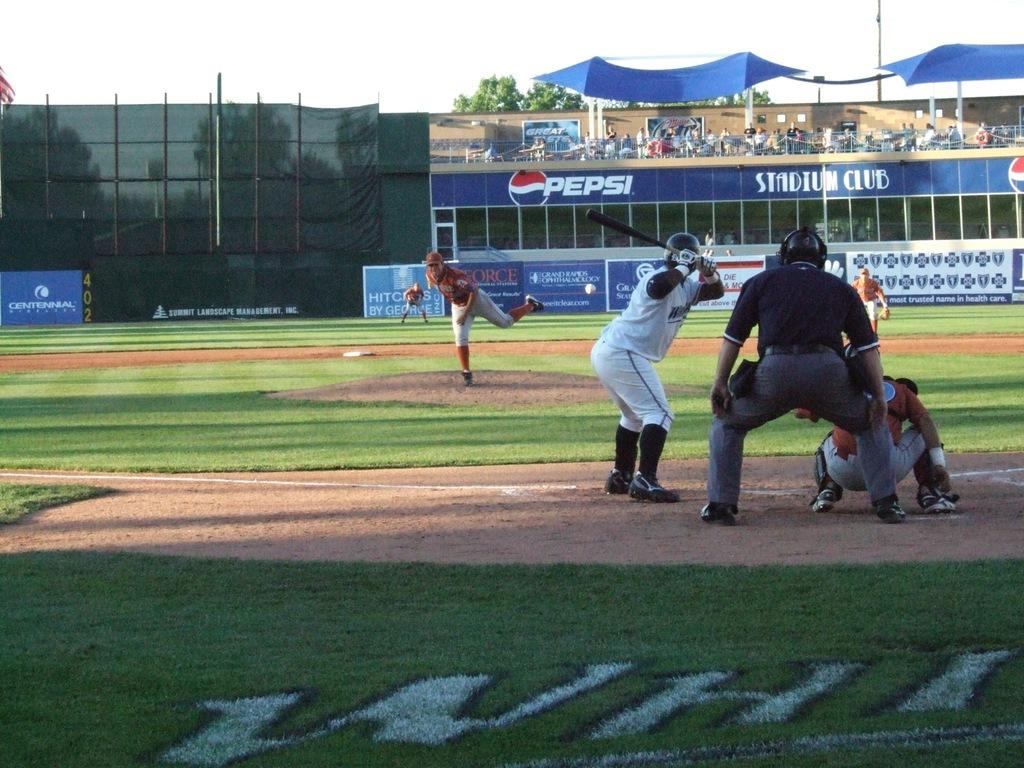What letters are painted on the grass?
Ensure brevity in your answer.  Whi. 